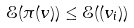<formula> <loc_0><loc_0><loc_500><loc_500>\mathcal { E } ( \pi ( v ) ) \leq \mathcal { E } ( ( v _ { i } ) )</formula> 